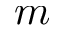<formula> <loc_0><loc_0><loc_500><loc_500>m</formula> 